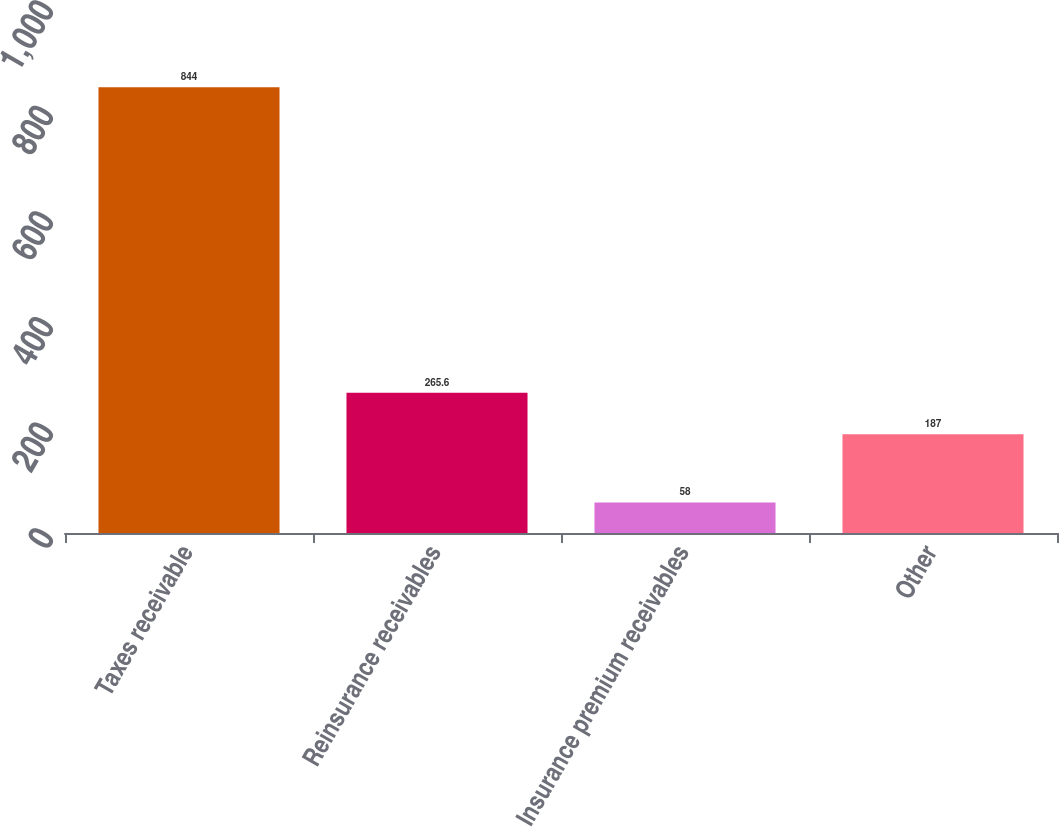Convert chart. <chart><loc_0><loc_0><loc_500><loc_500><bar_chart><fcel>Taxes receivable<fcel>Reinsurance receivables<fcel>Insurance premium receivables<fcel>Other<nl><fcel>844<fcel>265.6<fcel>58<fcel>187<nl></chart> 